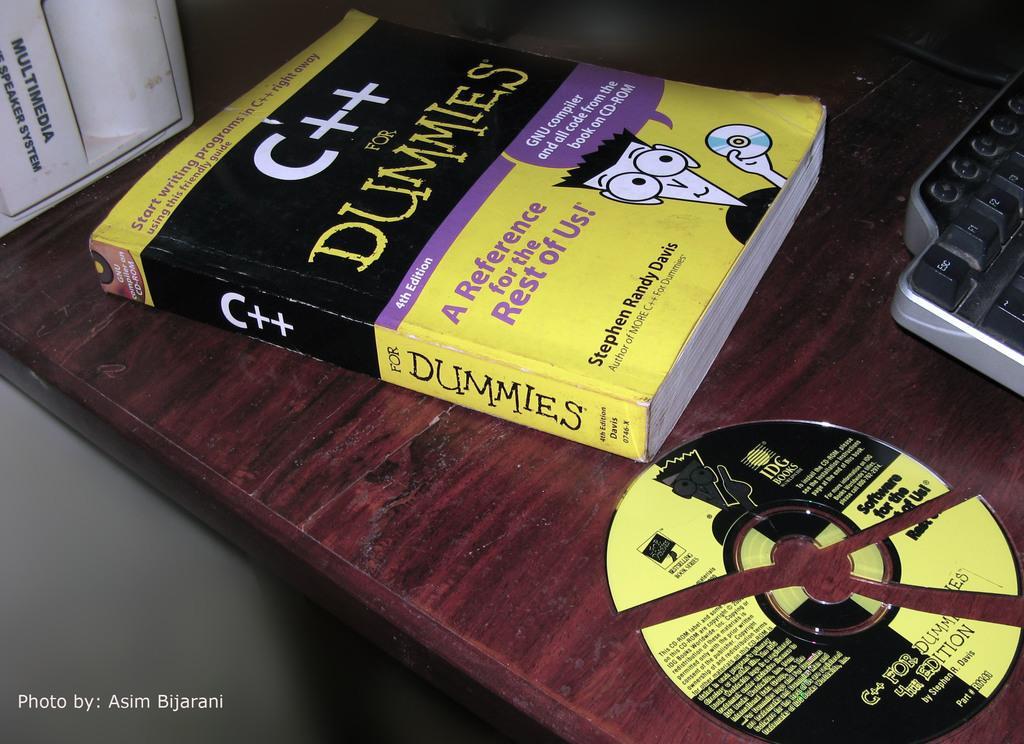Describe this image in one or two sentences. In this picture we can see one book, cutter disk and keyboard are placed on the table. 